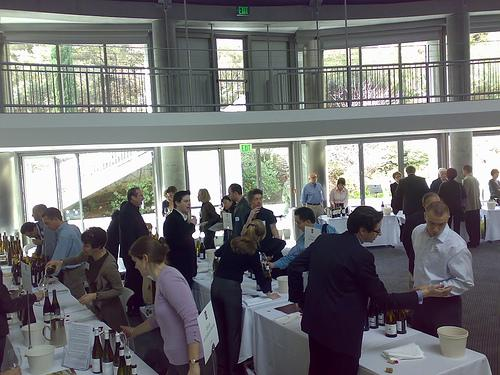What is on the table to the left? Please explain your reasoning. wine bottles. Tables are lined up with white linens and glass bottles in the middle. wine is served at formal events. 